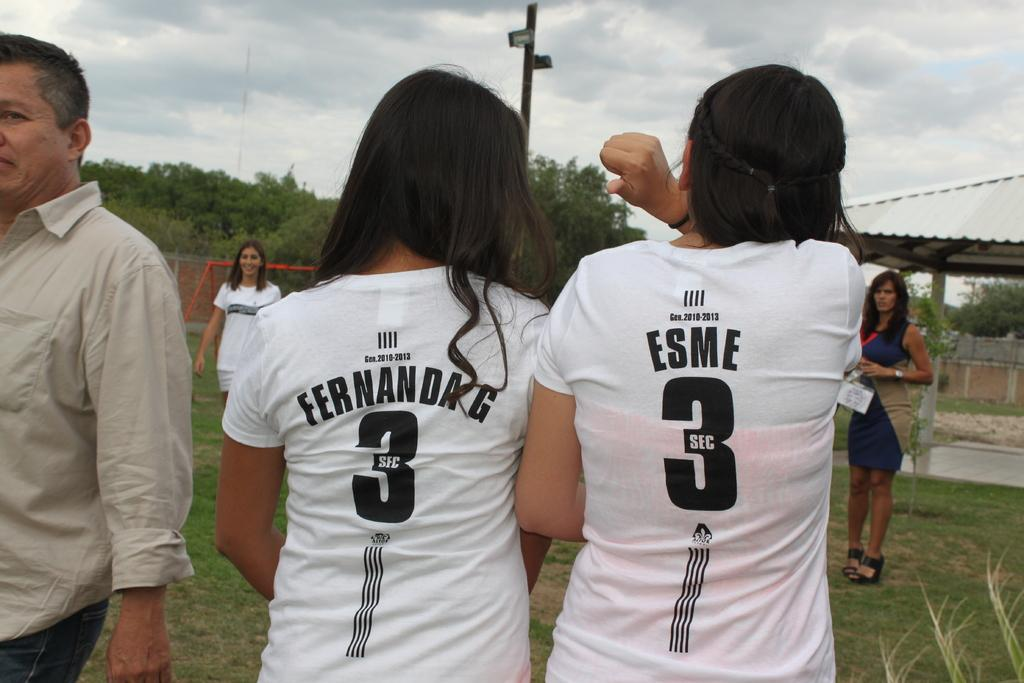<image>
Create a compact narrative representing the image presented. Player named Fernanda G standing next to another player named Esme. 